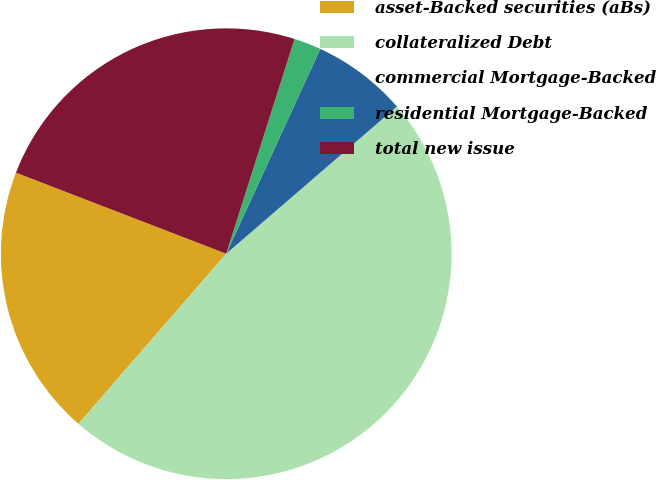Convert chart to OTSL. <chart><loc_0><loc_0><loc_500><loc_500><pie_chart><fcel>asset-Backed securities (aBs)<fcel>collateralized Debt<fcel>commercial Mortgage-Backed<fcel>residential Mortgage-Backed<fcel>total new issue<nl><fcel>19.47%<fcel>47.71%<fcel>6.82%<fcel>1.95%<fcel>24.05%<nl></chart> 